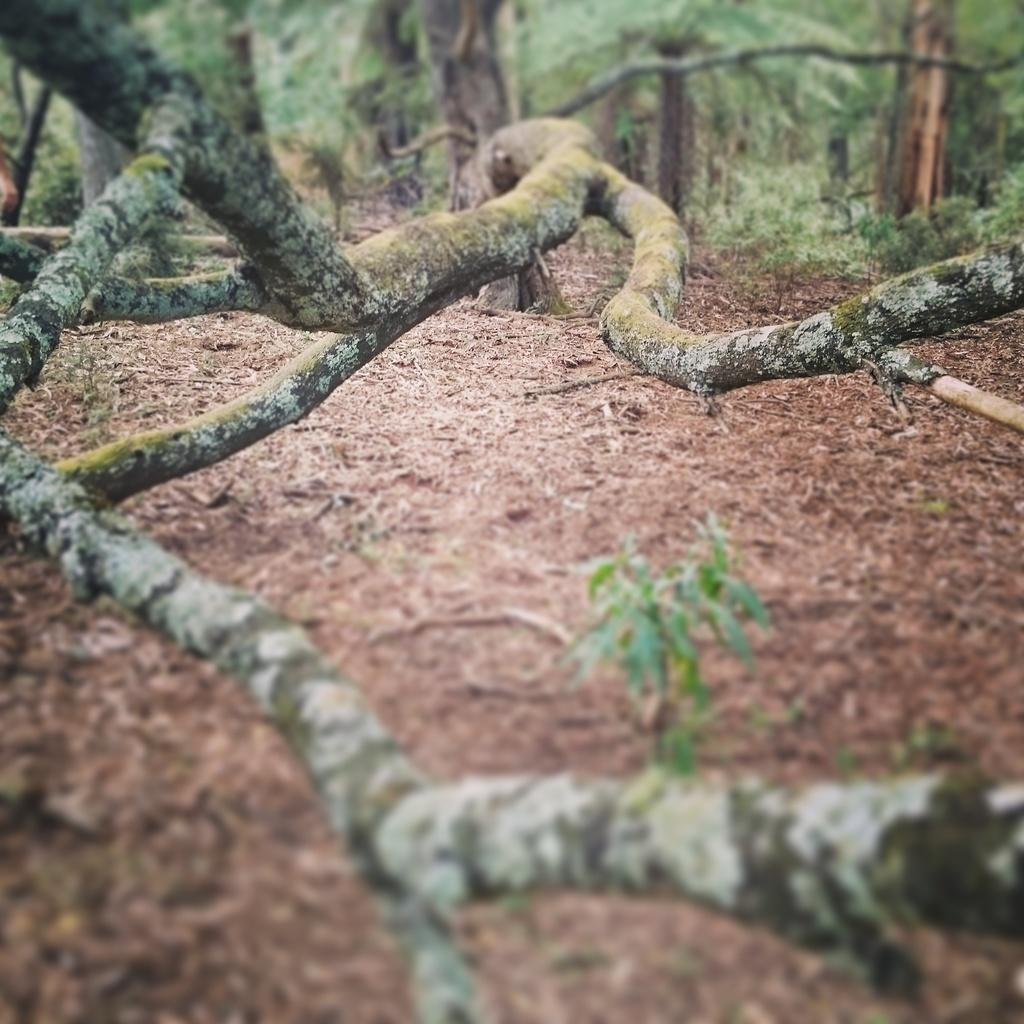What can be seen in the foreground of the image? There are tree branches in the foreground of the image. What is visible in the background of the image? There are trees in the background of the image. What type of ground is visible in the image? There is soil visible at the bottom of the image. Can you see any ghosts in the image? There are no ghosts present in the image. What is an example of a bird that might be found in the trees in the image? The image does not provide enough information to identify a specific bird species; it only shows trees and tree branches. 